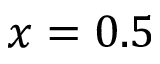Convert formula to latex. <formula><loc_0><loc_0><loc_500><loc_500>x = 0 . 5</formula> 